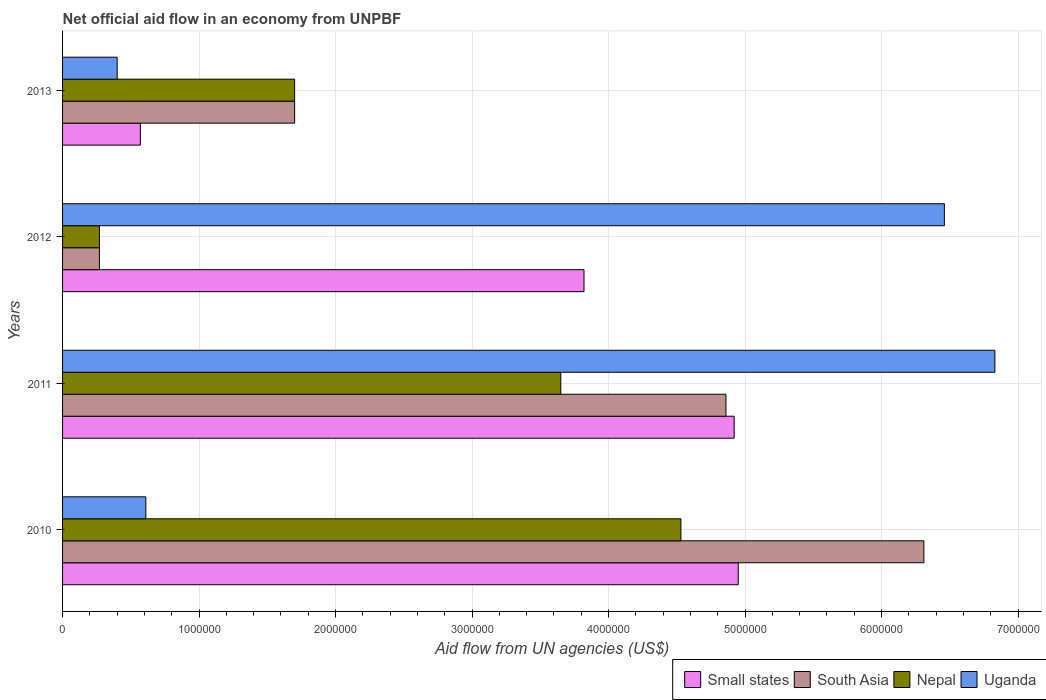How many different coloured bars are there?
Ensure brevity in your answer.  4. Are the number of bars per tick equal to the number of legend labels?
Your response must be concise. Yes. Are the number of bars on each tick of the Y-axis equal?
Offer a very short reply. Yes. What is the label of the 1st group of bars from the top?
Your answer should be compact. 2013. In how many cases, is the number of bars for a given year not equal to the number of legend labels?
Offer a terse response. 0. Across all years, what is the maximum net official aid flow in Small states?
Offer a terse response. 4.95e+06. Across all years, what is the minimum net official aid flow in South Asia?
Keep it short and to the point. 2.70e+05. What is the total net official aid flow in Nepal in the graph?
Offer a terse response. 1.02e+07. What is the difference between the net official aid flow in Uganda in 2011 and that in 2013?
Keep it short and to the point. 6.43e+06. What is the difference between the net official aid flow in South Asia in 2010 and the net official aid flow in Uganda in 2012?
Provide a short and direct response. -1.50e+05. What is the average net official aid flow in Small states per year?
Give a very brief answer. 3.56e+06. In the year 2011, what is the difference between the net official aid flow in Nepal and net official aid flow in Small states?
Your answer should be compact. -1.27e+06. What is the ratio of the net official aid flow in Uganda in 2010 to that in 2012?
Ensure brevity in your answer.  0.09. Is the net official aid flow in Nepal in 2010 less than that in 2011?
Keep it short and to the point. No. Is the difference between the net official aid flow in Nepal in 2010 and 2013 greater than the difference between the net official aid flow in Small states in 2010 and 2013?
Provide a succinct answer. No. What is the difference between the highest and the second highest net official aid flow in Nepal?
Ensure brevity in your answer.  8.80e+05. What is the difference between the highest and the lowest net official aid flow in Nepal?
Offer a terse response. 4.26e+06. Is the sum of the net official aid flow in Small states in 2010 and 2011 greater than the maximum net official aid flow in Uganda across all years?
Keep it short and to the point. Yes. What does the 2nd bar from the top in 2013 represents?
Offer a very short reply. Nepal. What does the 1st bar from the bottom in 2013 represents?
Provide a succinct answer. Small states. How many bars are there?
Provide a short and direct response. 16. Are all the bars in the graph horizontal?
Give a very brief answer. Yes. What is the difference between two consecutive major ticks on the X-axis?
Offer a terse response. 1.00e+06. Are the values on the major ticks of X-axis written in scientific E-notation?
Offer a terse response. No. Where does the legend appear in the graph?
Ensure brevity in your answer.  Bottom right. How many legend labels are there?
Give a very brief answer. 4. How are the legend labels stacked?
Make the answer very short. Horizontal. What is the title of the graph?
Offer a terse response. Net official aid flow in an economy from UNPBF. Does "Bosnia and Herzegovina" appear as one of the legend labels in the graph?
Make the answer very short. No. What is the label or title of the X-axis?
Offer a very short reply. Aid flow from UN agencies (US$). What is the label or title of the Y-axis?
Provide a succinct answer. Years. What is the Aid flow from UN agencies (US$) of Small states in 2010?
Offer a very short reply. 4.95e+06. What is the Aid flow from UN agencies (US$) in South Asia in 2010?
Offer a terse response. 6.31e+06. What is the Aid flow from UN agencies (US$) in Nepal in 2010?
Keep it short and to the point. 4.53e+06. What is the Aid flow from UN agencies (US$) in Small states in 2011?
Give a very brief answer. 4.92e+06. What is the Aid flow from UN agencies (US$) in South Asia in 2011?
Provide a succinct answer. 4.86e+06. What is the Aid flow from UN agencies (US$) of Nepal in 2011?
Offer a very short reply. 3.65e+06. What is the Aid flow from UN agencies (US$) of Uganda in 2011?
Keep it short and to the point. 6.83e+06. What is the Aid flow from UN agencies (US$) of Small states in 2012?
Provide a succinct answer. 3.82e+06. What is the Aid flow from UN agencies (US$) of Uganda in 2012?
Provide a succinct answer. 6.46e+06. What is the Aid flow from UN agencies (US$) in Small states in 2013?
Make the answer very short. 5.70e+05. What is the Aid flow from UN agencies (US$) in South Asia in 2013?
Your answer should be very brief. 1.70e+06. What is the Aid flow from UN agencies (US$) of Nepal in 2013?
Offer a very short reply. 1.70e+06. Across all years, what is the maximum Aid flow from UN agencies (US$) in Small states?
Your answer should be very brief. 4.95e+06. Across all years, what is the maximum Aid flow from UN agencies (US$) of South Asia?
Give a very brief answer. 6.31e+06. Across all years, what is the maximum Aid flow from UN agencies (US$) in Nepal?
Keep it short and to the point. 4.53e+06. Across all years, what is the maximum Aid flow from UN agencies (US$) in Uganda?
Your answer should be very brief. 6.83e+06. Across all years, what is the minimum Aid flow from UN agencies (US$) of Small states?
Ensure brevity in your answer.  5.70e+05. Across all years, what is the minimum Aid flow from UN agencies (US$) of Uganda?
Your answer should be compact. 4.00e+05. What is the total Aid flow from UN agencies (US$) of Small states in the graph?
Your answer should be very brief. 1.43e+07. What is the total Aid flow from UN agencies (US$) in South Asia in the graph?
Offer a very short reply. 1.31e+07. What is the total Aid flow from UN agencies (US$) of Nepal in the graph?
Offer a very short reply. 1.02e+07. What is the total Aid flow from UN agencies (US$) of Uganda in the graph?
Give a very brief answer. 1.43e+07. What is the difference between the Aid flow from UN agencies (US$) of South Asia in 2010 and that in 2011?
Make the answer very short. 1.45e+06. What is the difference between the Aid flow from UN agencies (US$) in Nepal in 2010 and that in 2011?
Your response must be concise. 8.80e+05. What is the difference between the Aid flow from UN agencies (US$) of Uganda in 2010 and that in 2011?
Your response must be concise. -6.22e+06. What is the difference between the Aid flow from UN agencies (US$) of Small states in 2010 and that in 2012?
Provide a short and direct response. 1.13e+06. What is the difference between the Aid flow from UN agencies (US$) in South Asia in 2010 and that in 2012?
Give a very brief answer. 6.04e+06. What is the difference between the Aid flow from UN agencies (US$) of Nepal in 2010 and that in 2012?
Give a very brief answer. 4.26e+06. What is the difference between the Aid flow from UN agencies (US$) of Uganda in 2010 and that in 2012?
Offer a terse response. -5.85e+06. What is the difference between the Aid flow from UN agencies (US$) of Small states in 2010 and that in 2013?
Your response must be concise. 4.38e+06. What is the difference between the Aid flow from UN agencies (US$) of South Asia in 2010 and that in 2013?
Make the answer very short. 4.61e+06. What is the difference between the Aid flow from UN agencies (US$) in Nepal in 2010 and that in 2013?
Keep it short and to the point. 2.83e+06. What is the difference between the Aid flow from UN agencies (US$) in Uganda in 2010 and that in 2013?
Your answer should be compact. 2.10e+05. What is the difference between the Aid flow from UN agencies (US$) in Small states in 2011 and that in 2012?
Ensure brevity in your answer.  1.10e+06. What is the difference between the Aid flow from UN agencies (US$) of South Asia in 2011 and that in 2012?
Make the answer very short. 4.59e+06. What is the difference between the Aid flow from UN agencies (US$) in Nepal in 2011 and that in 2012?
Offer a terse response. 3.38e+06. What is the difference between the Aid flow from UN agencies (US$) in Uganda in 2011 and that in 2012?
Offer a terse response. 3.70e+05. What is the difference between the Aid flow from UN agencies (US$) of Small states in 2011 and that in 2013?
Your answer should be compact. 4.35e+06. What is the difference between the Aid flow from UN agencies (US$) of South Asia in 2011 and that in 2013?
Offer a terse response. 3.16e+06. What is the difference between the Aid flow from UN agencies (US$) in Nepal in 2011 and that in 2013?
Provide a succinct answer. 1.95e+06. What is the difference between the Aid flow from UN agencies (US$) in Uganda in 2011 and that in 2013?
Your answer should be compact. 6.43e+06. What is the difference between the Aid flow from UN agencies (US$) of Small states in 2012 and that in 2013?
Your answer should be compact. 3.25e+06. What is the difference between the Aid flow from UN agencies (US$) of South Asia in 2012 and that in 2013?
Offer a terse response. -1.43e+06. What is the difference between the Aid flow from UN agencies (US$) of Nepal in 2012 and that in 2013?
Offer a terse response. -1.43e+06. What is the difference between the Aid flow from UN agencies (US$) in Uganda in 2012 and that in 2013?
Give a very brief answer. 6.06e+06. What is the difference between the Aid flow from UN agencies (US$) of Small states in 2010 and the Aid flow from UN agencies (US$) of Nepal in 2011?
Your response must be concise. 1.30e+06. What is the difference between the Aid flow from UN agencies (US$) of Small states in 2010 and the Aid flow from UN agencies (US$) of Uganda in 2011?
Your answer should be very brief. -1.88e+06. What is the difference between the Aid flow from UN agencies (US$) in South Asia in 2010 and the Aid flow from UN agencies (US$) in Nepal in 2011?
Keep it short and to the point. 2.66e+06. What is the difference between the Aid flow from UN agencies (US$) in South Asia in 2010 and the Aid flow from UN agencies (US$) in Uganda in 2011?
Provide a short and direct response. -5.20e+05. What is the difference between the Aid flow from UN agencies (US$) in Nepal in 2010 and the Aid flow from UN agencies (US$) in Uganda in 2011?
Keep it short and to the point. -2.30e+06. What is the difference between the Aid flow from UN agencies (US$) of Small states in 2010 and the Aid flow from UN agencies (US$) of South Asia in 2012?
Your answer should be very brief. 4.68e+06. What is the difference between the Aid flow from UN agencies (US$) of Small states in 2010 and the Aid flow from UN agencies (US$) of Nepal in 2012?
Provide a succinct answer. 4.68e+06. What is the difference between the Aid flow from UN agencies (US$) of Small states in 2010 and the Aid flow from UN agencies (US$) of Uganda in 2012?
Provide a short and direct response. -1.51e+06. What is the difference between the Aid flow from UN agencies (US$) in South Asia in 2010 and the Aid flow from UN agencies (US$) in Nepal in 2012?
Keep it short and to the point. 6.04e+06. What is the difference between the Aid flow from UN agencies (US$) of Nepal in 2010 and the Aid flow from UN agencies (US$) of Uganda in 2012?
Give a very brief answer. -1.93e+06. What is the difference between the Aid flow from UN agencies (US$) of Small states in 2010 and the Aid flow from UN agencies (US$) of South Asia in 2013?
Make the answer very short. 3.25e+06. What is the difference between the Aid flow from UN agencies (US$) of Small states in 2010 and the Aid flow from UN agencies (US$) of Nepal in 2013?
Your answer should be very brief. 3.25e+06. What is the difference between the Aid flow from UN agencies (US$) in Small states in 2010 and the Aid flow from UN agencies (US$) in Uganda in 2013?
Your answer should be compact. 4.55e+06. What is the difference between the Aid flow from UN agencies (US$) in South Asia in 2010 and the Aid flow from UN agencies (US$) in Nepal in 2013?
Give a very brief answer. 4.61e+06. What is the difference between the Aid flow from UN agencies (US$) of South Asia in 2010 and the Aid flow from UN agencies (US$) of Uganda in 2013?
Give a very brief answer. 5.91e+06. What is the difference between the Aid flow from UN agencies (US$) in Nepal in 2010 and the Aid flow from UN agencies (US$) in Uganda in 2013?
Give a very brief answer. 4.13e+06. What is the difference between the Aid flow from UN agencies (US$) of Small states in 2011 and the Aid flow from UN agencies (US$) of South Asia in 2012?
Provide a short and direct response. 4.65e+06. What is the difference between the Aid flow from UN agencies (US$) of Small states in 2011 and the Aid flow from UN agencies (US$) of Nepal in 2012?
Offer a very short reply. 4.65e+06. What is the difference between the Aid flow from UN agencies (US$) in Small states in 2011 and the Aid flow from UN agencies (US$) in Uganda in 2012?
Provide a succinct answer. -1.54e+06. What is the difference between the Aid flow from UN agencies (US$) of South Asia in 2011 and the Aid flow from UN agencies (US$) of Nepal in 2012?
Offer a very short reply. 4.59e+06. What is the difference between the Aid flow from UN agencies (US$) in South Asia in 2011 and the Aid flow from UN agencies (US$) in Uganda in 2012?
Provide a short and direct response. -1.60e+06. What is the difference between the Aid flow from UN agencies (US$) of Nepal in 2011 and the Aid flow from UN agencies (US$) of Uganda in 2012?
Provide a short and direct response. -2.81e+06. What is the difference between the Aid flow from UN agencies (US$) in Small states in 2011 and the Aid flow from UN agencies (US$) in South Asia in 2013?
Offer a very short reply. 3.22e+06. What is the difference between the Aid flow from UN agencies (US$) in Small states in 2011 and the Aid flow from UN agencies (US$) in Nepal in 2013?
Your answer should be compact. 3.22e+06. What is the difference between the Aid flow from UN agencies (US$) in Small states in 2011 and the Aid flow from UN agencies (US$) in Uganda in 2013?
Ensure brevity in your answer.  4.52e+06. What is the difference between the Aid flow from UN agencies (US$) in South Asia in 2011 and the Aid flow from UN agencies (US$) in Nepal in 2013?
Your answer should be compact. 3.16e+06. What is the difference between the Aid flow from UN agencies (US$) of South Asia in 2011 and the Aid flow from UN agencies (US$) of Uganda in 2013?
Ensure brevity in your answer.  4.46e+06. What is the difference between the Aid flow from UN agencies (US$) of Nepal in 2011 and the Aid flow from UN agencies (US$) of Uganda in 2013?
Ensure brevity in your answer.  3.25e+06. What is the difference between the Aid flow from UN agencies (US$) in Small states in 2012 and the Aid flow from UN agencies (US$) in South Asia in 2013?
Your response must be concise. 2.12e+06. What is the difference between the Aid flow from UN agencies (US$) in Small states in 2012 and the Aid flow from UN agencies (US$) in Nepal in 2013?
Your answer should be compact. 2.12e+06. What is the difference between the Aid flow from UN agencies (US$) of Small states in 2012 and the Aid flow from UN agencies (US$) of Uganda in 2013?
Offer a very short reply. 3.42e+06. What is the difference between the Aid flow from UN agencies (US$) of South Asia in 2012 and the Aid flow from UN agencies (US$) of Nepal in 2013?
Keep it short and to the point. -1.43e+06. What is the difference between the Aid flow from UN agencies (US$) in South Asia in 2012 and the Aid flow from UN agencies (US$) in Uganda in 2013?
Give a very brief answer. -1.30e+05. What is the average Aid flow from UN agencies (US$) in Small states per year?
Offer a terse response. 3.56e+06. What is the average Aid flow from UN agencies (US$) of South Asia per year?
Your answer should be compact. 3.28e+06. What is the average Aid flow from UN agencies (US$) of Nepal per year?
Your answer should be very brief. 2.54e+06. What is the average Aid flow from UN agencies (US$) of Uganda per year?
Provide a short and direct response. 3.58e+06. In the year 2010, what is the difference between the Aid flow from UN agencies (US$) in Small states and Aid flow from UN agencies (US$) in South Asia?
Your answer should be compact. -1.36e+06. In the year 2010, what is the difference between the Aid flow from UN agencies (US$) in Small states and Aid flow from UN agencies (US$) in Nepal?
Your response must be concise. 4.20e+05. In the year 2010, what is the difference between the Aid flow from UN agencies (US$) in Small states and Aid flow from UN agencies (US$) in Uganda?
Ensure brevity in your answer.  4.34e+06. In the year 2010, what is the difference between the Aid flow from UN agencies (US$) of South Asia and Aid flow from UN agencies (US$) of Nepal?
Your response must be concise. 1.78e+06. In the year 2010, what is the difference between the Aid flow from UN agencies (US$) in South Asia and Aid flow from UN agencies (US$) in Uganda?
Your answer should be very brief. 5.70e+06. In the year 2010, what is the difference between the Aid flow from UN agencies (US$) in Nepal and Aid flow from UN agencies (US$) in Uganda?
Your response must be concise. 3.92e+06. In the year 2011, what is the difference between the Aid flow from UN agencies (US$) in Small states and Aid flow from UN agencies (US$) in Nepal?
Provide a succinct answer. 1.27e+06. In the year 2011, what is the difference between the Aid flow from UN agencies (US$) in Small states and Aid flow from UN agencies (US$) in Uganda?
Provide a succinct answer. -1.91e+06. In the year 2011, what is the difference between the Aid flow from UN agencies (US$) in South Asia and Aid flow from UN agencies (US$) in Nepal?
Offer a terse response. 1.21e+06. In the year 2011, what is the difference between the Aid flow from UN agencies (US$) in South Asia and Aid flow from UN agencies (US$) in Uganda?
Keep it short and to the point. -1.97e+06. In the year 2011, what is the difference between the Aid flow from UN agencies (US$) of Nepal and Aid flow from UN agencies (US$) of Uganda?
Offer a very short reply. -3.18e+06. In the year 2012, what is the difference between the Aid flow from UN agencies (US$) in Small states and Aid flow from UN agencies (US$) in South Asia?
Give a very brief answer. 3.55e+06. In the year 2012, what is the difference between the Aid flow from UN agencies (US$) of Small states and Aid flow from UN agencies (US$) of Nepal?
Your response must be concise. 3.55e+06. In the year 2012, what is the difference between the Aid flow from UN agencies (US$) of Small states and Aid flow from UN agencies (US$) of Uganda?
Your response must be concise. -2.64e+06. In the year 2012, what is the difference between the Aid flow from UN agencies (US$) of South Asia and Aid flow from UN agencies (US$) of Nepal?
Offer a terse response. 0. In the year 2012, what is the difference between the Aid flow from UN agencies (US$) in South Asia and Aid flow from UN agencies (US$) in Uganda?
Your response must be concise. -6.19e+06. In the year 2012, what is the difference between the Aid flow from UN agencies (US$) in Nepal and Aid flow from UN agencies (US$) in Uganda?
Provide a succinct answer. -6.19e+06. In the year 2013, what is the difference between the Aid flow from UN agencies (US$) of Small states and Aid flow from UN agencies (US$) of South Asia?
Provide a short and direct response. -1.13e+06. In the year 2013, what is the difference between the Aid flow from UN agencies (US$) in Small states and Aid flow from UN agencies (US$) in Nepal?
Provide a succinct answer. -1.13e+06. In the year 2013, what is the difference between the Aid flow from UN agencies (US$) in Small states and Aid flow from UN agencies (US$) in Uganda?
Make the answer very short. 1.70e+05. In the year 2013, what is the difference between the Aid flow from UN agencies (US$) of South Asia and Aid flow from UN agencies (US$) of Nepal?
Keep it short and to the point. 0. In the year 2013, what is the difference between the Aid flow from UN agencies (US$) of South Asia and Aid flow from UN agencies (US$) of Uganda?
Ensure brevity in your answer.  1.30e+06. In the year 2013, what is the difference between the Aid flow from UN agencies (US$) of Nepal and Aid flow from UN agencies (US$) of Uganda?
Your answer should be very brief. 1.30e+06. What is the ratio of the Aid flow from UN agencies (US$) in South Asia in 2010 to that in 2011?
Your response must be concise. 1.3. What is the ratio of the Aid flow from UN agencies (US$) of Nepal in 2010 to that in 2011?
Offer a very short reply. 1.24. What is the ratio of the Aid flow from UN agencies (US$) of Uganda in 2010 to that in 2011?
Keep it short and to the point. 0.09. What is the ratio of the Aid flow from UN agencies (US$) in Small states in 2010 to that in 2012?
Your answer should be compact. 1.3. What is the ratio of the Aid flow from UN agencies (US$) in South Asia in 2010 to that in 2012?
Provide a succinct answer. 23.37. What is the ratio of the Aid flow from UN agencies (US$) of Nepal in 2010 to that in 2012?
Ensure brevity in your answer.  16.78. What is the ratio of the Aid flow from UN agencies (US$) in Uganda in 2010 to that in 2012?
Give a very brief answer. 0.09. What is the ratio of the Aid flow from UN agencies (US$) in Small states in 2010 to that in 2013?
Keep it short and to the point. 8.68. What is the ratio of the Aid flow from UN agencies (US$) in South Asia in 2010 to that in 2013?
Make the answer very short. 3.71. What is the ratio of the Aid flow from UN agencies (US$) in Nepal in 2010 to that in 2013?
Your response must be concise. 2.66. What is the ratio of the Aid flow from UN agencies (US$) of Uganda in 2010 to that in 2013?
Keep it short and to the point. 1.52. What is the ratio of the Aid flow from UN agencies (US$) in Small states in 2011 to that in 2012?
Offer a terse response. 1.29. What is the ratio of the Aid flow from UN agencies (US$) in South Asia in 2011 to that in 2012?
Give a very brief answer. 18. What is the ratio of the Aid flow from UN agencies (US$) in Nepal in 2011 to that in 2012?
Your answer should be very brief. 13.52. What is the ratio of the Aid flow from UN agencies (US$) of Uganda in 2011 to that in 2012?
Ensure brevity in your answer.  1.06. What is the ratio of the Aid flow from UN agencies (US$) in Small states in 2011 to that in 2013?
Provide a succinct answer. 8.63. What is the ratio of the Aid flow from UN agencies (US$) in South Asia in 2011 to that in 2013?
Ensure brevity in your answer.  2.86. What is the ratio of the Aid flow from UN agencies (US$) in Nepal in 2011 to that in 2013?
Your answer should be compact. 2.15. What is the ratio of the Aid flow from UN agencies (US$) in Uganda in 2011 to that in 2013?
Ensure brevity in your answer.  17.07. What is the ratio of the Aid flow from UN agencies (US$) in Small states in 2012 to that in 2013?
Your answer should be very brief. 6.7. What is the ratio of the Aid flow from UN agencies (US$) of South Asia in 2012 to that in 2013?
Make the answer very short. 0.16. What is the ratio of the Aid flow from UN agencies (US$) of Nepal in 2012 to that in 2013?
Keep it short and to the point. 0.16. What is the ratio of the Aid flow from UN agencies (US$) of Uganda in 2012 to that in 2013?
Provide a succinct answer. 16.15. What is the difference between the highest and the second highest Aid flow from UN agencies (US$) of South Asia?
Ensure brevity in your answer.  1.45e+06. What is the difference between the highest and the second highest Aid flow from UN agencies (US$) in Nepal?
Provide a short and direct response. 8.80e+05. What is the difference between the highest and the second highest Aid flow from UN agencies (US$) of Uganda?
Ensure brevity in your answer.  3.70e+05. What is the difference between the highest and the lowest Aid flow from UN agencies (US$) of Small states?
Your answer should be compact. 4.38e+06. What is the difference between the highest and the lowest Aid flow from UN agencies (US$) in South Asia?
Give a very brief answer. 6.04e+06. What is the difference between the highest and the lowest Aid flow from UN agencies (US$) in Nepal?
Ensure brevity in your answer.  4.26e+06. What is the difference between the highest and the lowest Aid flow from UN agencies (US$) of Uganda?
Provide a succinct answer. 6.43e+06. 